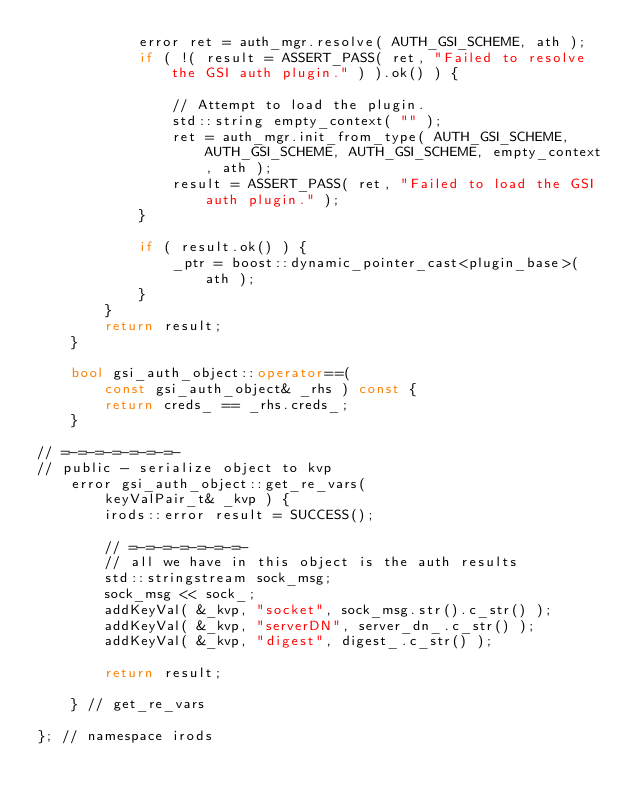Convert code to text. <code><loc_0><loc_0><loc_500><loc_500><_C++_>            error ret = auth_mgr.resolve( AUTH_GSI_SCHEME, ath );
            if ( !( result = ASSERT_PASS( ret, "Failed to resolve the GSI auth plugin." ) ).ok() ) {

                // Attempt to load the plugin.
                std::string empty_context( "" );
                ret = auth_mgr.init_from_type( AUTH_GSI_SCHEME, AUTH_GSI_SCHEME, AUTH_GSI_SCHEME, empty_context, ath );
                result = ASSERT_PASS( ret, "Failed to load the GSI auth plugin." );
            }

            if ( result.ok() ) {
                _ptr = boost::dynamic_pointer_cast<plugin_base>( ath );
            }
        }
        return result;
    }

    bool gsi_auth_object::operator==(
        const gsi_auth_object& _rhs ) const {
        return creds_ == _rhs.creds_;
    }

// =-=-=-=-=-=-=-
// public - serialize object to kvp
    error gsi_auth_object::get_re_vars(
        keyValPair_t& _kvp ) {
        irods::error result = SUCCESS();

        // =-=-=-=-=-=-=-
        // all we have in this object is the auth results
        std::stringstream sock_msg;
        sock_msg << sock_;
        addKeyVal( &_kvp, "socket", sock_msg.str().c_str() );
        addKeyVal( &_kvp, "serverDN", server_dn_.c_str() );
        addKeyVal( &_kvp, "digest", digest_.c_str() );

        return result;

    } // get_re_vars

}; // namespace irods
</code> 